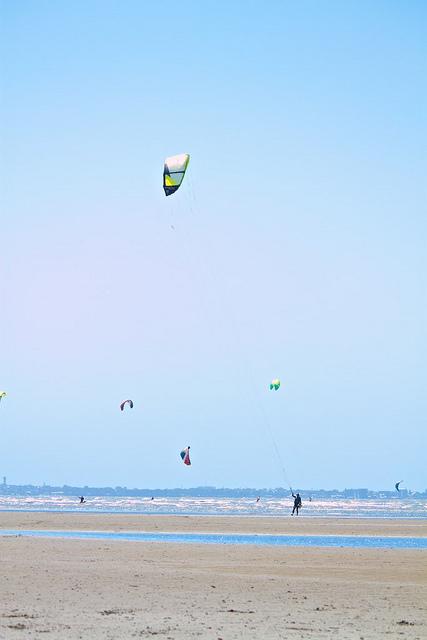Are these people on a beach?
Short answer required. Yes. What is flying in the sky?
Give a very brief answer. Kite. What color is the sky?
Be succinct. Blue. How many kites are flying in the air?
Concise answer only. 4. Was this picture taken in Nevada?
Quick response, please. No. 